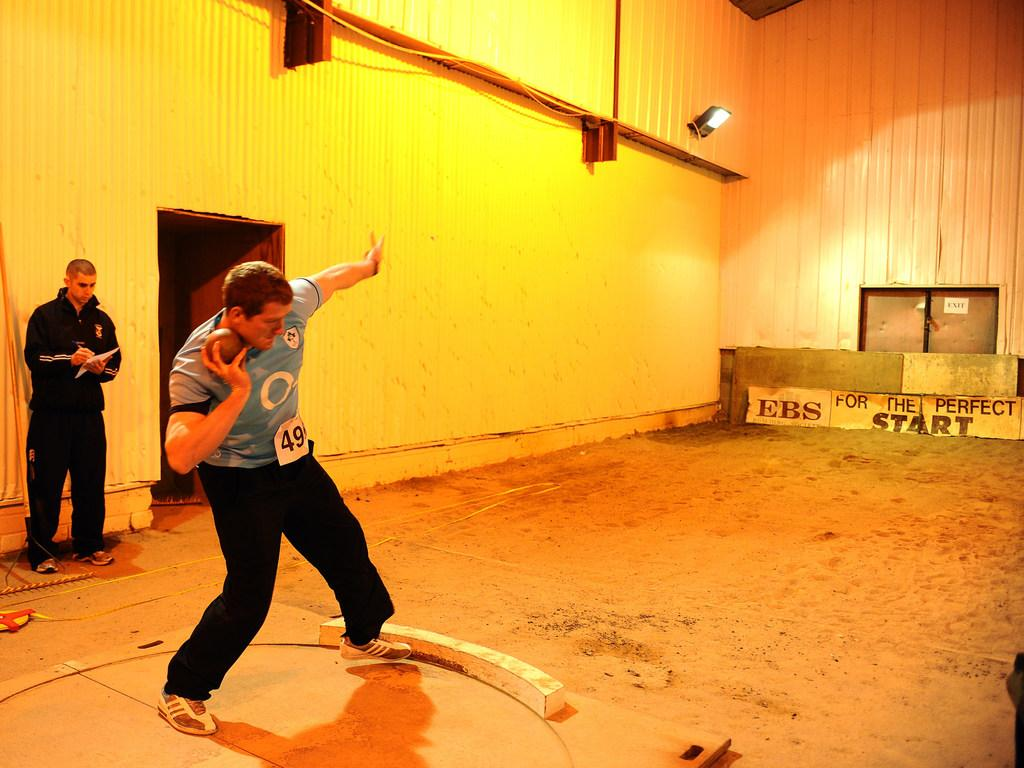What is the main action taking place in the image? There is a person throwing a shot put in the image. Can you describe the other person in the image? There is another person standing in the image, and he is holding a paper in his hand. What might the person holding the paper be doing? The person holding the paper might be observing the shot put throw or waiting for his turn. What type of engine is visible in the image? There is no engine present in the image. Is there a trade happening between the two people in the image? There is no indication of a trade taking place between the two people in the image. 